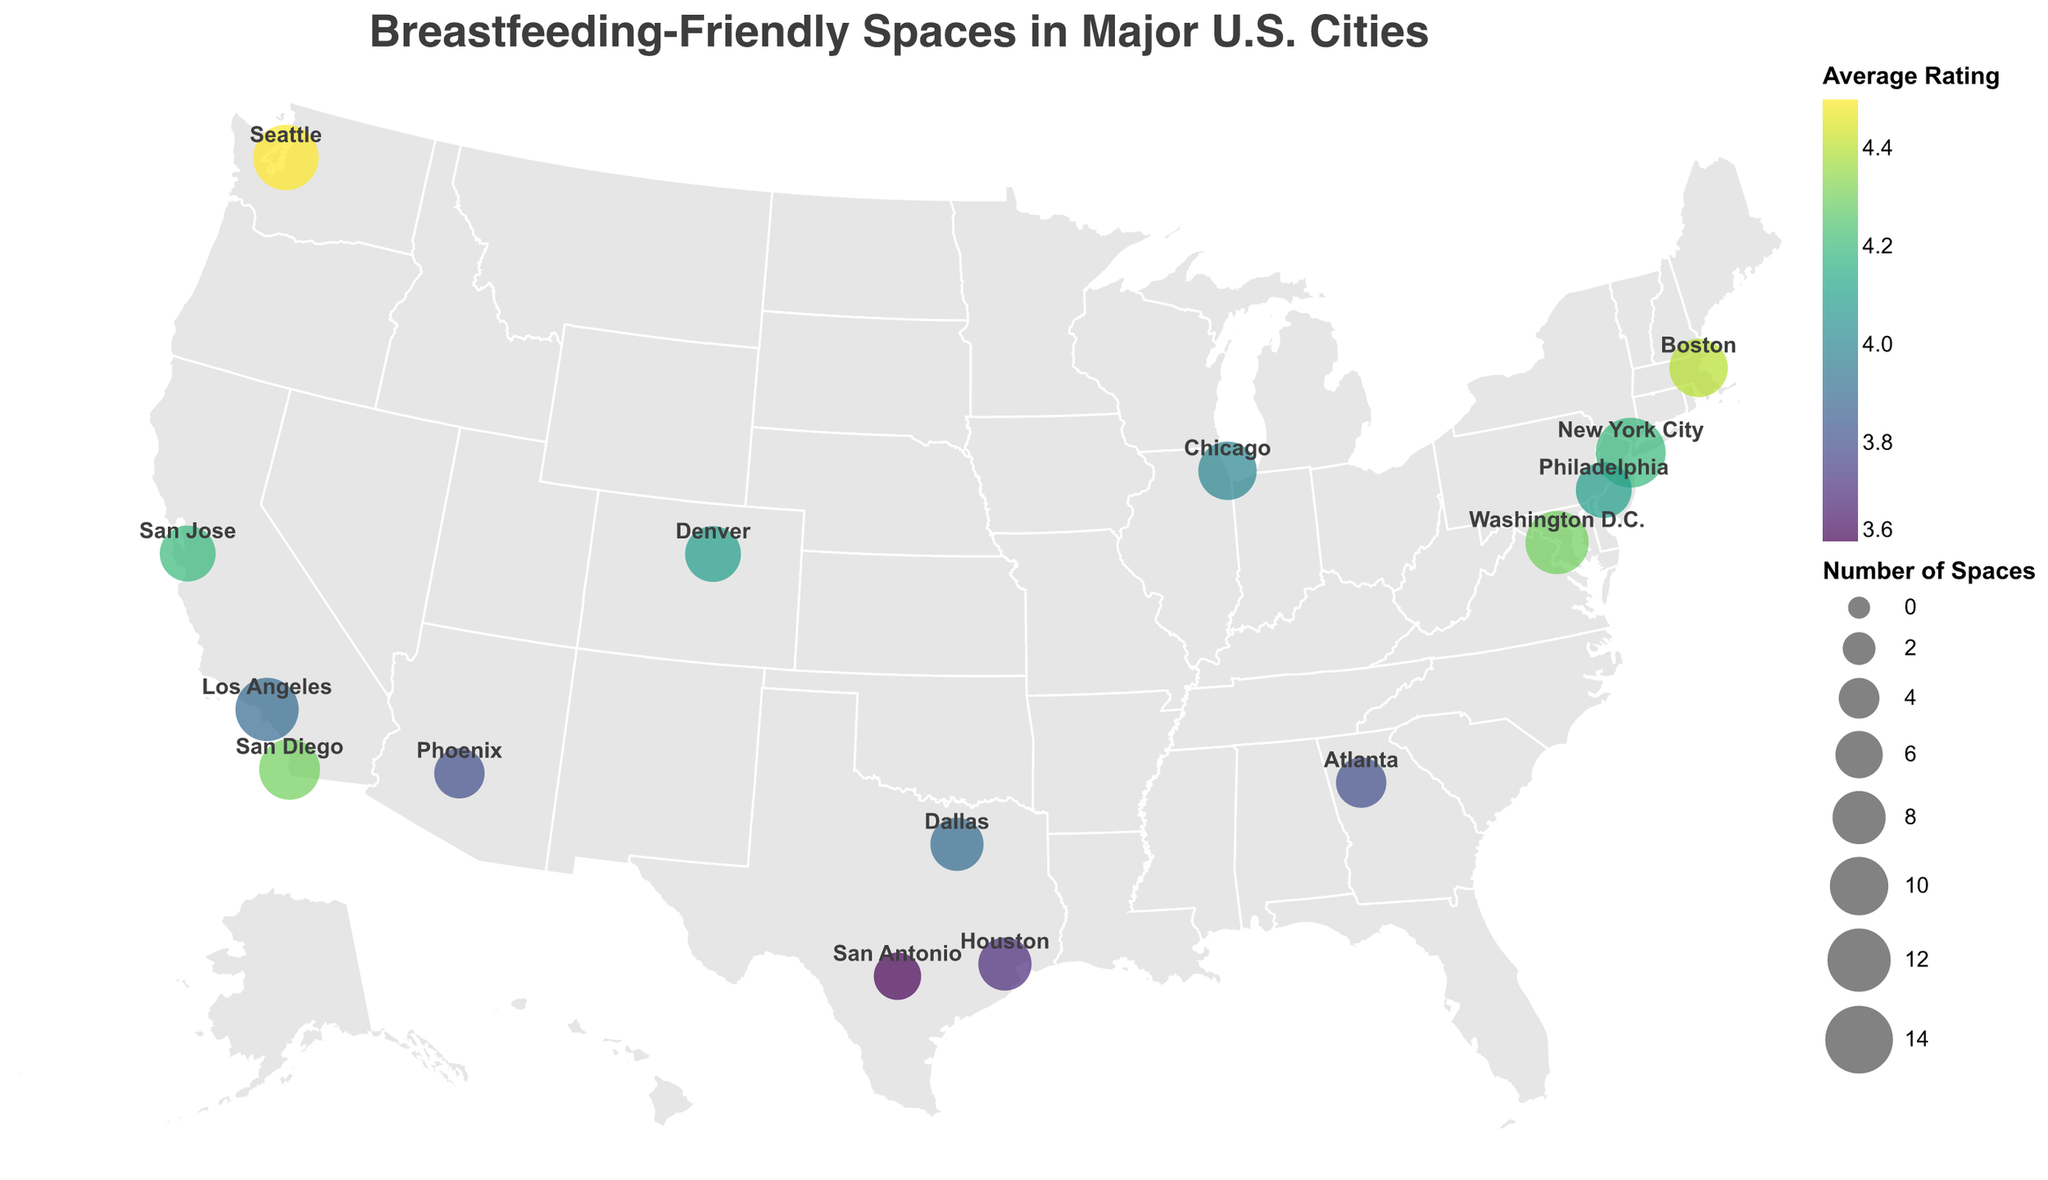What city has the highest number of breastfeeding-friendly spaces? Look at the size of the circles representing the number of breastfeeding-friendly spaces. The city with the largest circle is New York City.
Answer: New York City Which city has the highest average rating for its breastfeeding-friendly spaces? Look at the color intensity of the circles; the city with the most intense color has the highest rating. Seattle has the most vibrant color.
Answer: Seattle How many cities have an average rating of 4.0 or higher? Identify the cities with circles in shades corresponding to an average rating of 4.0 or higher. New York City, Philadelphia, San Jose, Seattle, Boston, San Diego, and Washington D.C. all meet this criterion.
Answer: 7 Which city has the lowest number of breastfeeding-friendly spaces and what is its average rating? Find the smallest circle on the map to locate the city with the fewest spaces. San Antonio has the fewest spaces, and its rating is shown with a color indicating an average rating of 3.6.
Answer: San Antonio, 3.6 Compare the number of breastfeeding-friendly spaces between New York City and Los Angeles. Which city has more, and by how many? Compare the sizes of the circles . New York City has 15 spaces, and Los Angeles has 12 spaces. Subtract 12 from 15.
Answer: New York City has 3 more spaces Which city shows a higher average rating, Phoenix or Atlanta? Look at the color of the circles representing Phoenix and Atlanta. Phoenix's circle is slightly lighter than Atlanta's, indicating a higher average rating.
Answer: Phoenix Calculate the total number of breastfeeding-friendly spaces for all cities combined. Sum the numbers of breastfeeding-friendly spaces for all cities: 15 + 12 + 10 + 8 + 7 + 9 + 6 + 11 + 8 + 9 + 13 + 10 + 9 + 12 + 7 = 146.
Answer: 146 Are there any cities with the same number of breastfeeding-friendly spaces but different average ratings? If yes, which ones? Identify cities with circles of the same size but different colors. Chicago and Boston both have 10 spaces but different ratings (4.0 and 4.4 respectively).
Answer: Chicago and Boston What is the average number of breastfeeding-friendly spaces across these cities? Sum the number of breastfeeding-friendly spaces and divide by the number of cities. (146 total spaces / 15 cities = 9.73)
Answer: 9.73 Which city has the smallest number of breastfeeding-friendly spaces with an average rating of 4.0 or higher? Look for the smallest circle among the circles with colors indicating a rating of 4.0 or higher. Philadelphia has 9 spaces with a rating of 4.1, so it qualifies.
Answer: Philadelphia 